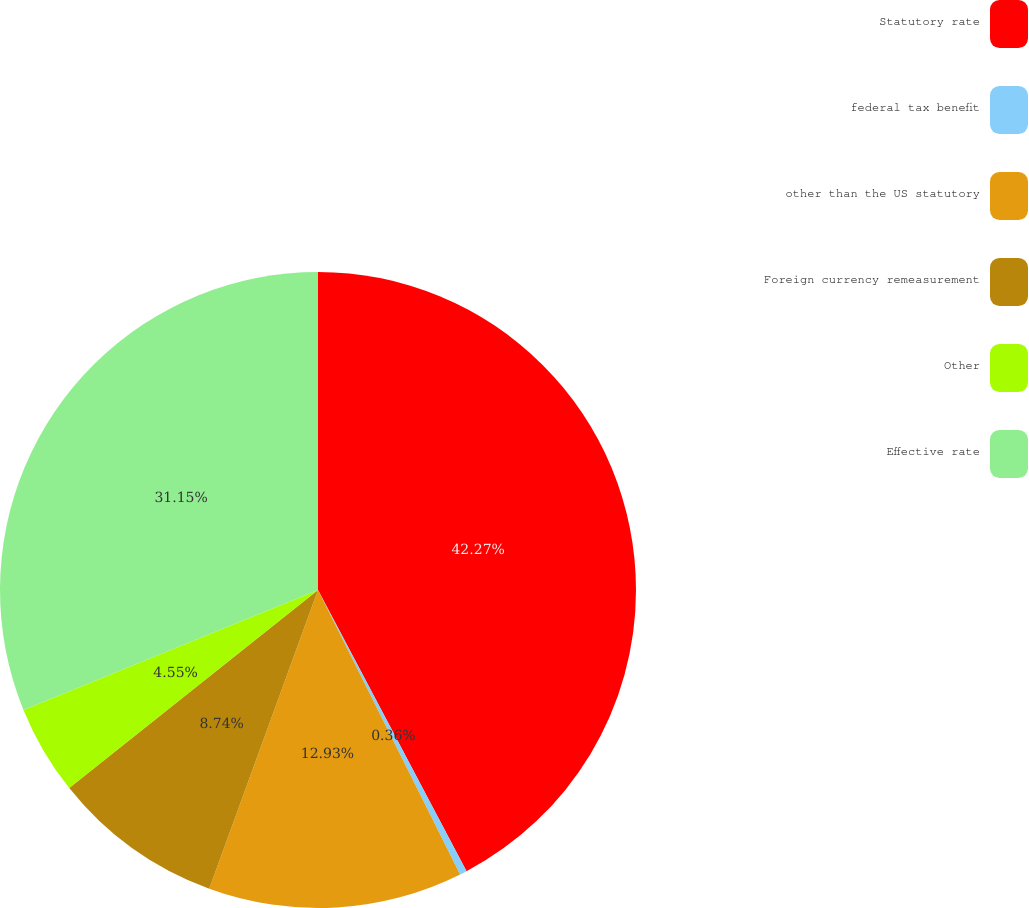Convert chart to OTSL. <chart><loc_0><loc_0><loc_500><loc_500><pie_chart><fcel>Statutory rate<fcel>federal tax benefit<fcel>other than the US statutory<fcel>Foreign currency remeasurement<fcel>Other<fcel>Effective rate<nl><fcel>42.26%<fcel>0.36%<fcel>12.93%<fcel>8.74%<fcel>4.55%<fcel>31.15%<nl></chart> 